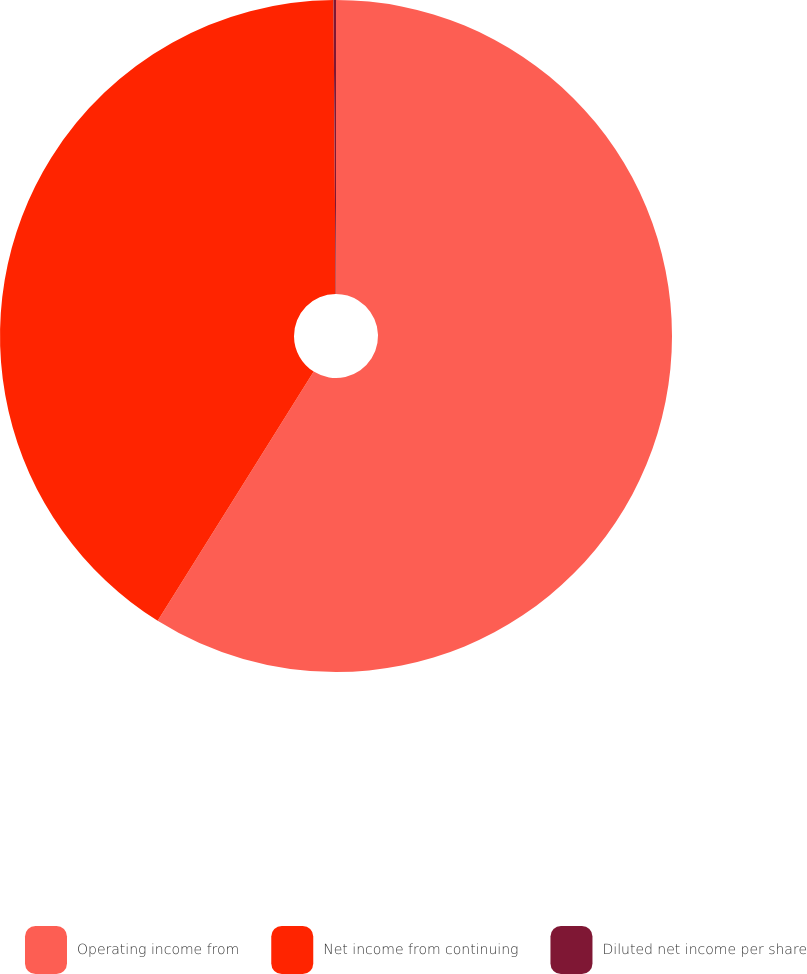Convert chart to OTSL. <chart><loc_0><loc_0><loc_500><loc_500><pie_chart><fcel>Operating income from<fcel>Net income from continuing<fcel>Diluted net income per share<nl><fcel>58.91%<fcel>40.98%<fcel>0.12%<nl></chart> 